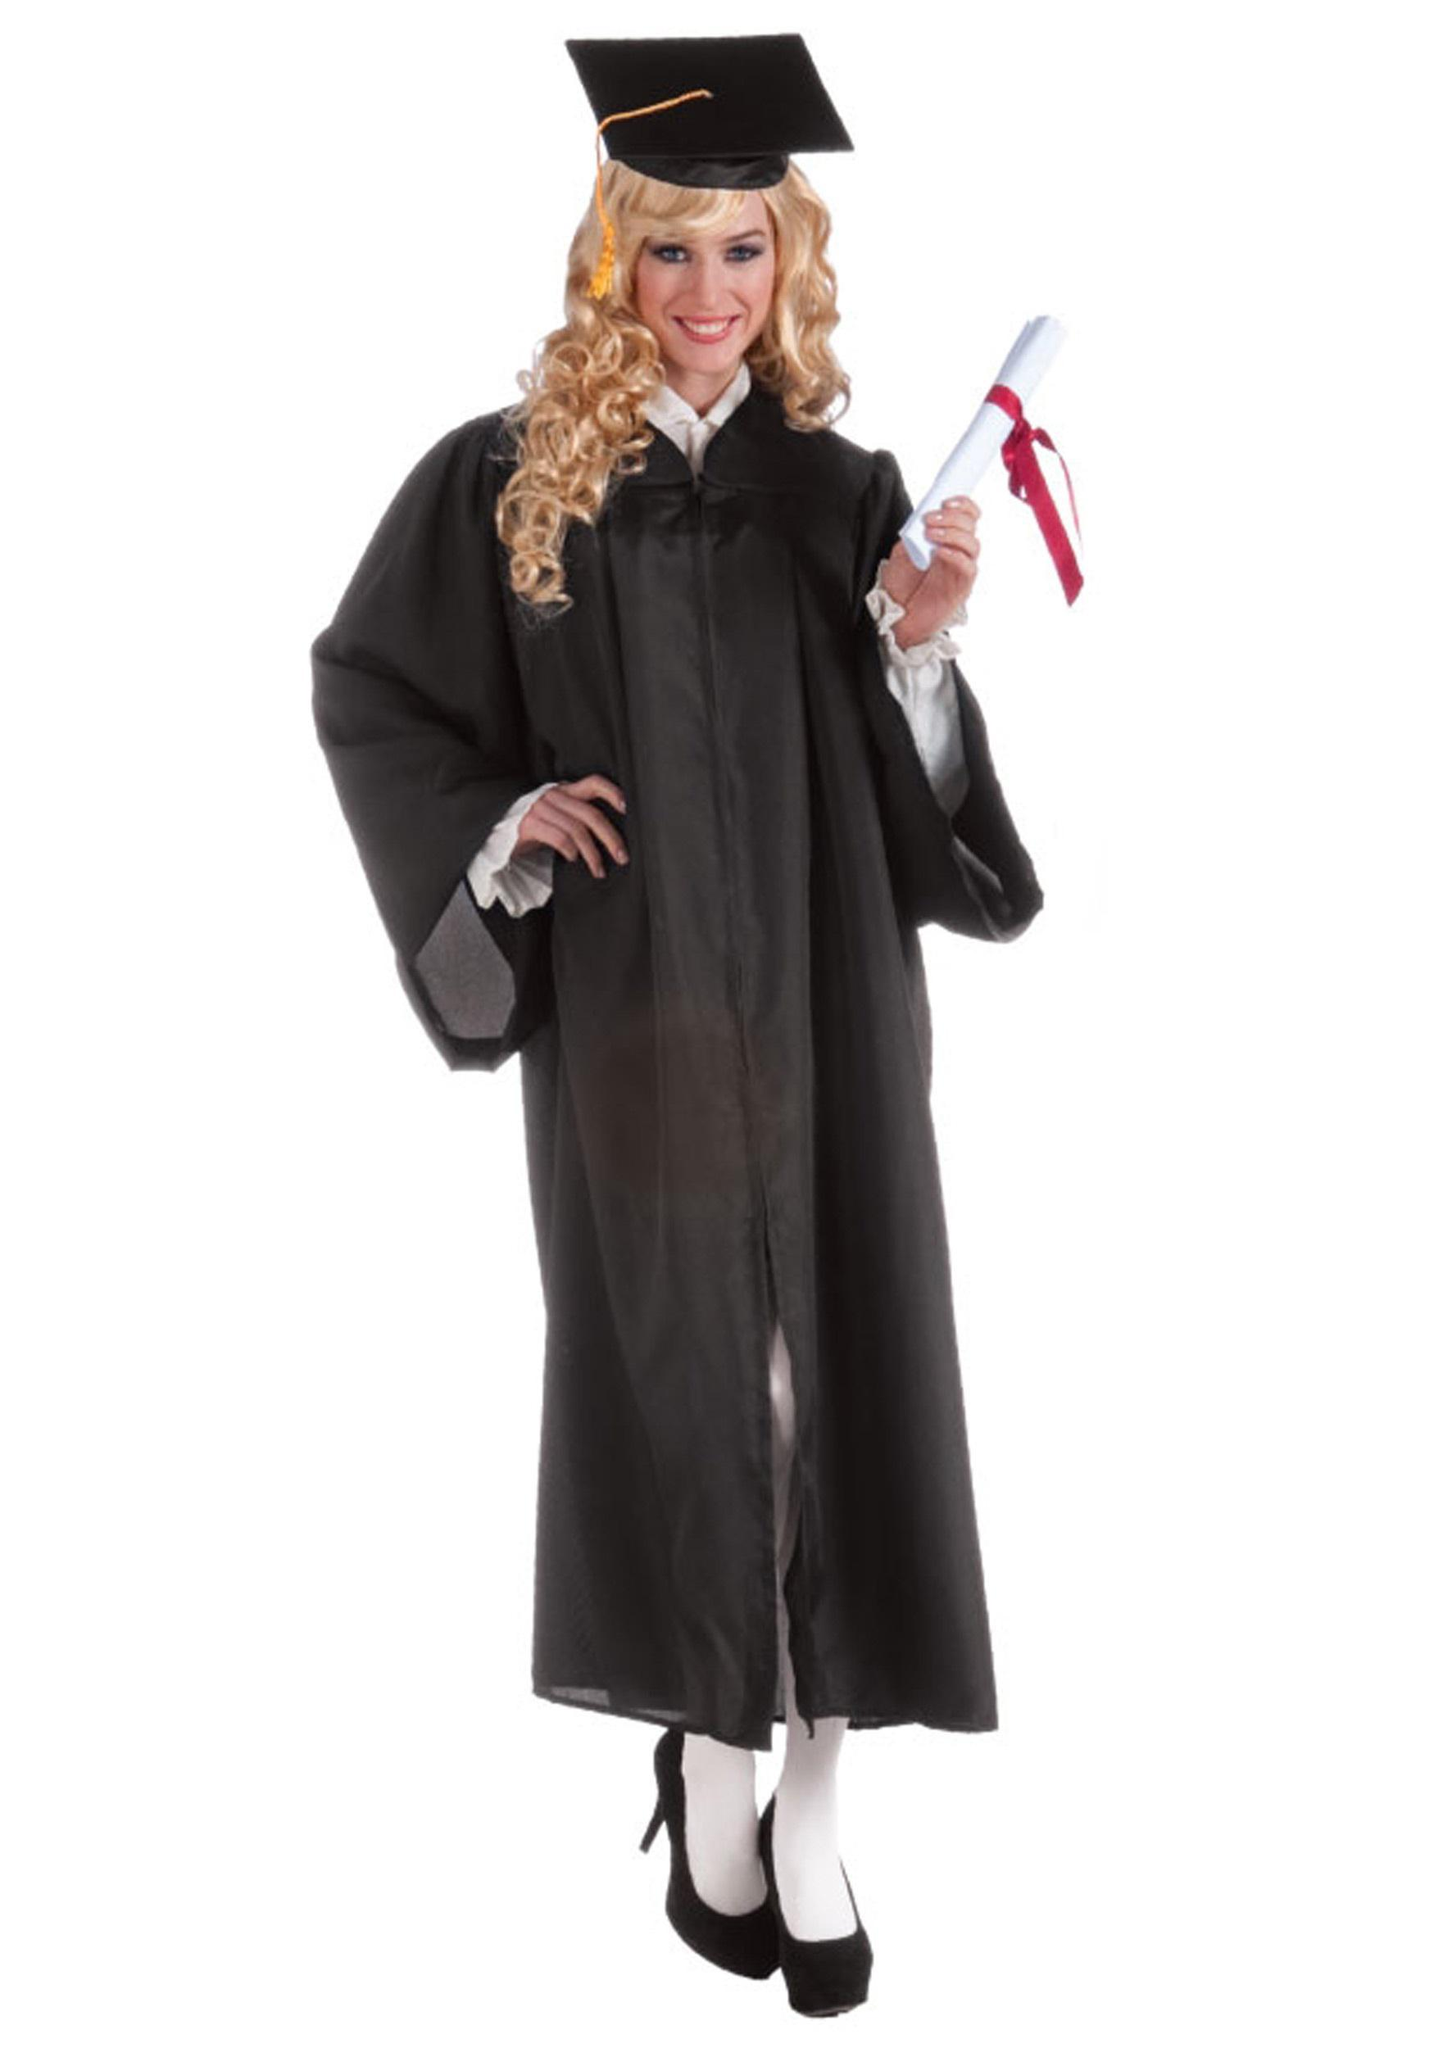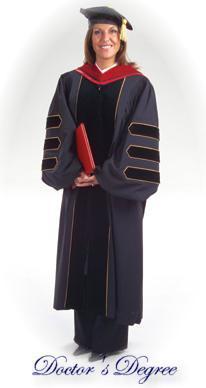The first image is the image on the left, the second image is the image on the right. For the images shown, is this caption "Each of the graduation gowns is being modeled by an actual person." true? Answer yes or no. Yes. The first image is the image on the left, the second image is the image on the right. Considering the images on both sides, is "One image shows a graduation outfit modeled by a real man, and the other image contains at least one graduation robe on a headless mannequin form." valid? Answer yes or no. No. 